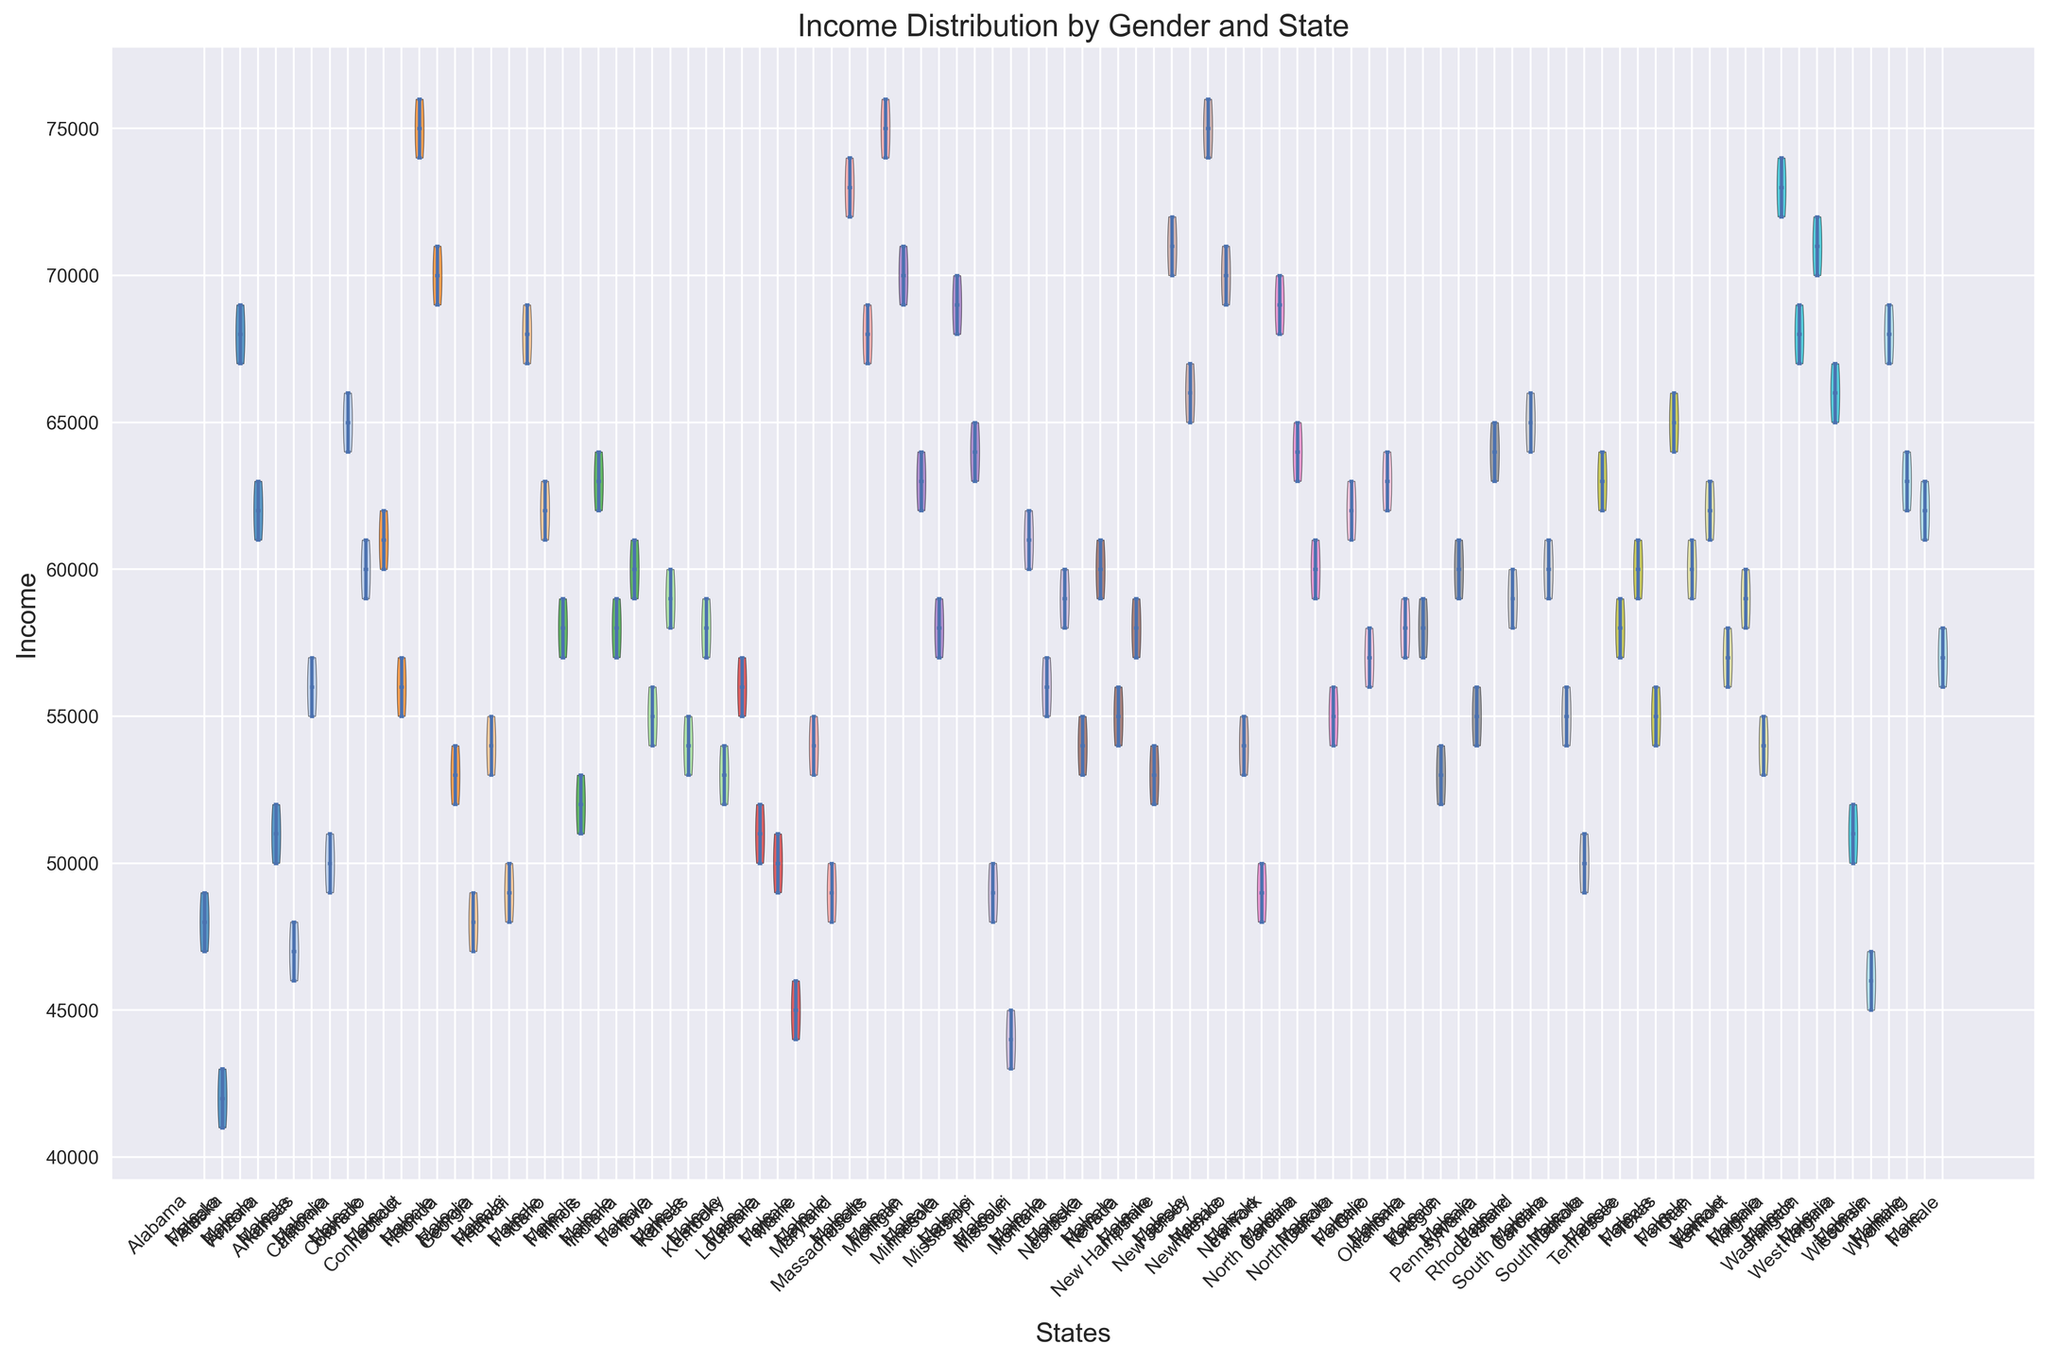Which state has the largest income gap between males and females? To determine which state has the largest income gap, we should observe the median points on the violin plots for both males and females in each state. The state with the most significant vertical difference between these medians has the largest income gap.
Answer: Connecticut Which state shows the closest median income between males and females? Identify the states where the median lines for males and females are nearly at the same level.
Answer: Alabama Which state has the highest median male income? Look at the median points in the violin plots for males across all states and identify the highest one.
Answer: New Jersey Are there more states with higher male income medians compared to female income medians? Count the number of states where the median for males is higher than the median for females and compare it to the reverse scenario.
Answer: Yes Which state has the widest distribution of male incomes? Find the violin plot for males with the largest range (widest shape) indicating the largest spread in income data.
Answer: California Does any state have overlapping median incomes for males and females? Check if the median lines for males and females overlap within the same state.
Answer: No Which state has the narrowest income distribution for females? Look for the violin plot with the least width for females, indicating a narrow range of income data.
Answer: Alabama How do the income distributions compare between Virginia and Texas for females? Compare the shapes, widths, and medians of female incomes between Virginia and Texas. Check which one is wider and if the medians are noticeably different.
Answer: Virginia is wider, Virginia median is higher Do any states have overlapping distributions for males and females, despite different medians? Identify states where the distributions of males and females (the widths of the violins) overlap significantly, even if their medians do not.
Answer: Yes, several states Which state has the lowest median income for females? Check the median points for females across all states to find the smallest one.
Answer: Mississippi 